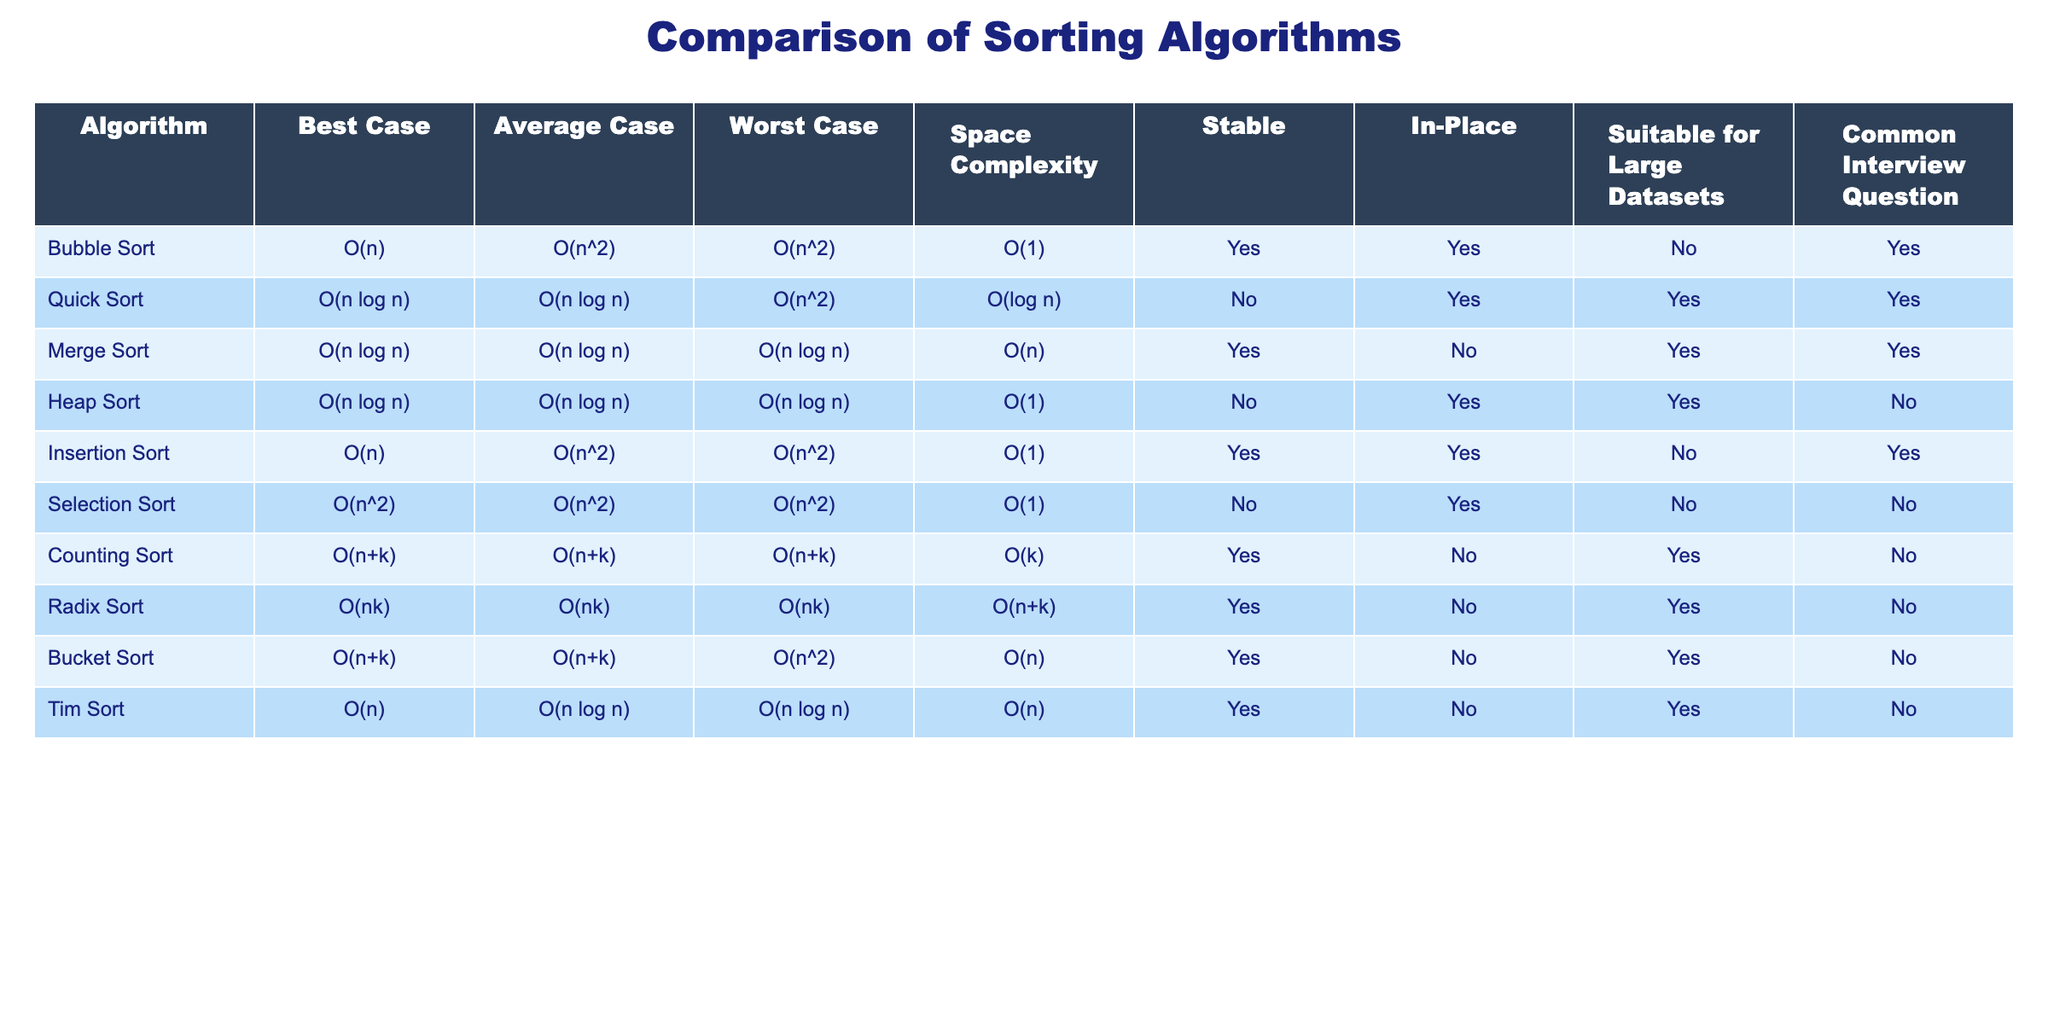What is the worst-case time complexity of Merge Sort? Looking at the table, the worst-case time complexity of Merge Sort is listed in the corresponding row under the "Worst Case" column, which reads O(n log n).
Answer: O(n log n) Is Quick Sort stable? Referring to the "Stable" column in the row for Quick Sort, it indicates "No," which means it is not a stable algorithm.
Answer: No What is the space complexity of Counting Sort? Checking the "Space Complexity" column for Counting Sort, it shows O(k), where k represents the range of the input values.
Answer: O(k) Which sorting algorithms have the best-case time complexity of O(n)? Reviewing the "Best Case" column, the algorithms with this time complexity are Bubble Sort, Insertion Sort, and Tim Sort.
Answer: Bubble Sort, Insertion Sort, Tim Sort What is the average time complexity of Heap Sort compared to Insertion Sort? Heap Sort has an average time complexity of O(n log n) and Insertion Sort has O(n^2). The average time complexity of Heap Sort is significantly faster than that of Insertion Sort.
Answer: O(n log n) is faster than O(n^2) Among the sorting algorithms listed, which are suitable for large datasets? Looking at the "Suitable for Large Datasets" column, the algorithms suitable for large datasets are Quick Sort, Merge Sort, Heap Sort, Counting Sort, Radix Sort, Tim Sort.
Answer: Quick Sort, Merge Sort, Heap Sort, Counting Sort, Radix Sort, Tim Sort What is the total number of sorting algorithms listed in the table that are in-place? Counting the "In-Place" column, we find that there are five algorithms that are in-place: Bubble Sort, Quick Sort, Insertion Sort, Selection Sort, and Heap Sort.
Answer: 5 Which algorithm has the lowest worst-case time complexity among the following: Quick Sort, Merge Sort, and Heap Sort? For Quick Sort, the worst-case complexity is O(n^2), for Merge Sort it is O(n log n), and for Heap Sort it is also O(n log n). Therefore, Quick Sort has the lowest worst-case complexity.
Answer: Quick Sort Is there any sorting algorithm with both O(n) best-case and average-case time complexity? In reviewing both the "Best Case" and "Average Case" columns, it can be seen that Bubble Sort and Insertion Sort have the best-case of O(n) but their average case is O(n^2), so no algorithm meets the criteria for both cases.
Answer: No 